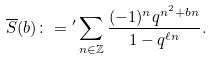<formula> <loc_0><loc_0><loc_500><loc_500>\overline { S } ( b ) \colon = { ^ { \prime } } \sum _ { n \in \mathbb { Z } } \frac { ( - 1 ) ^ { n } q ^ { n ^ { 2 } + b n } } { 1 - q ^ { \ell n } } .</formula> 